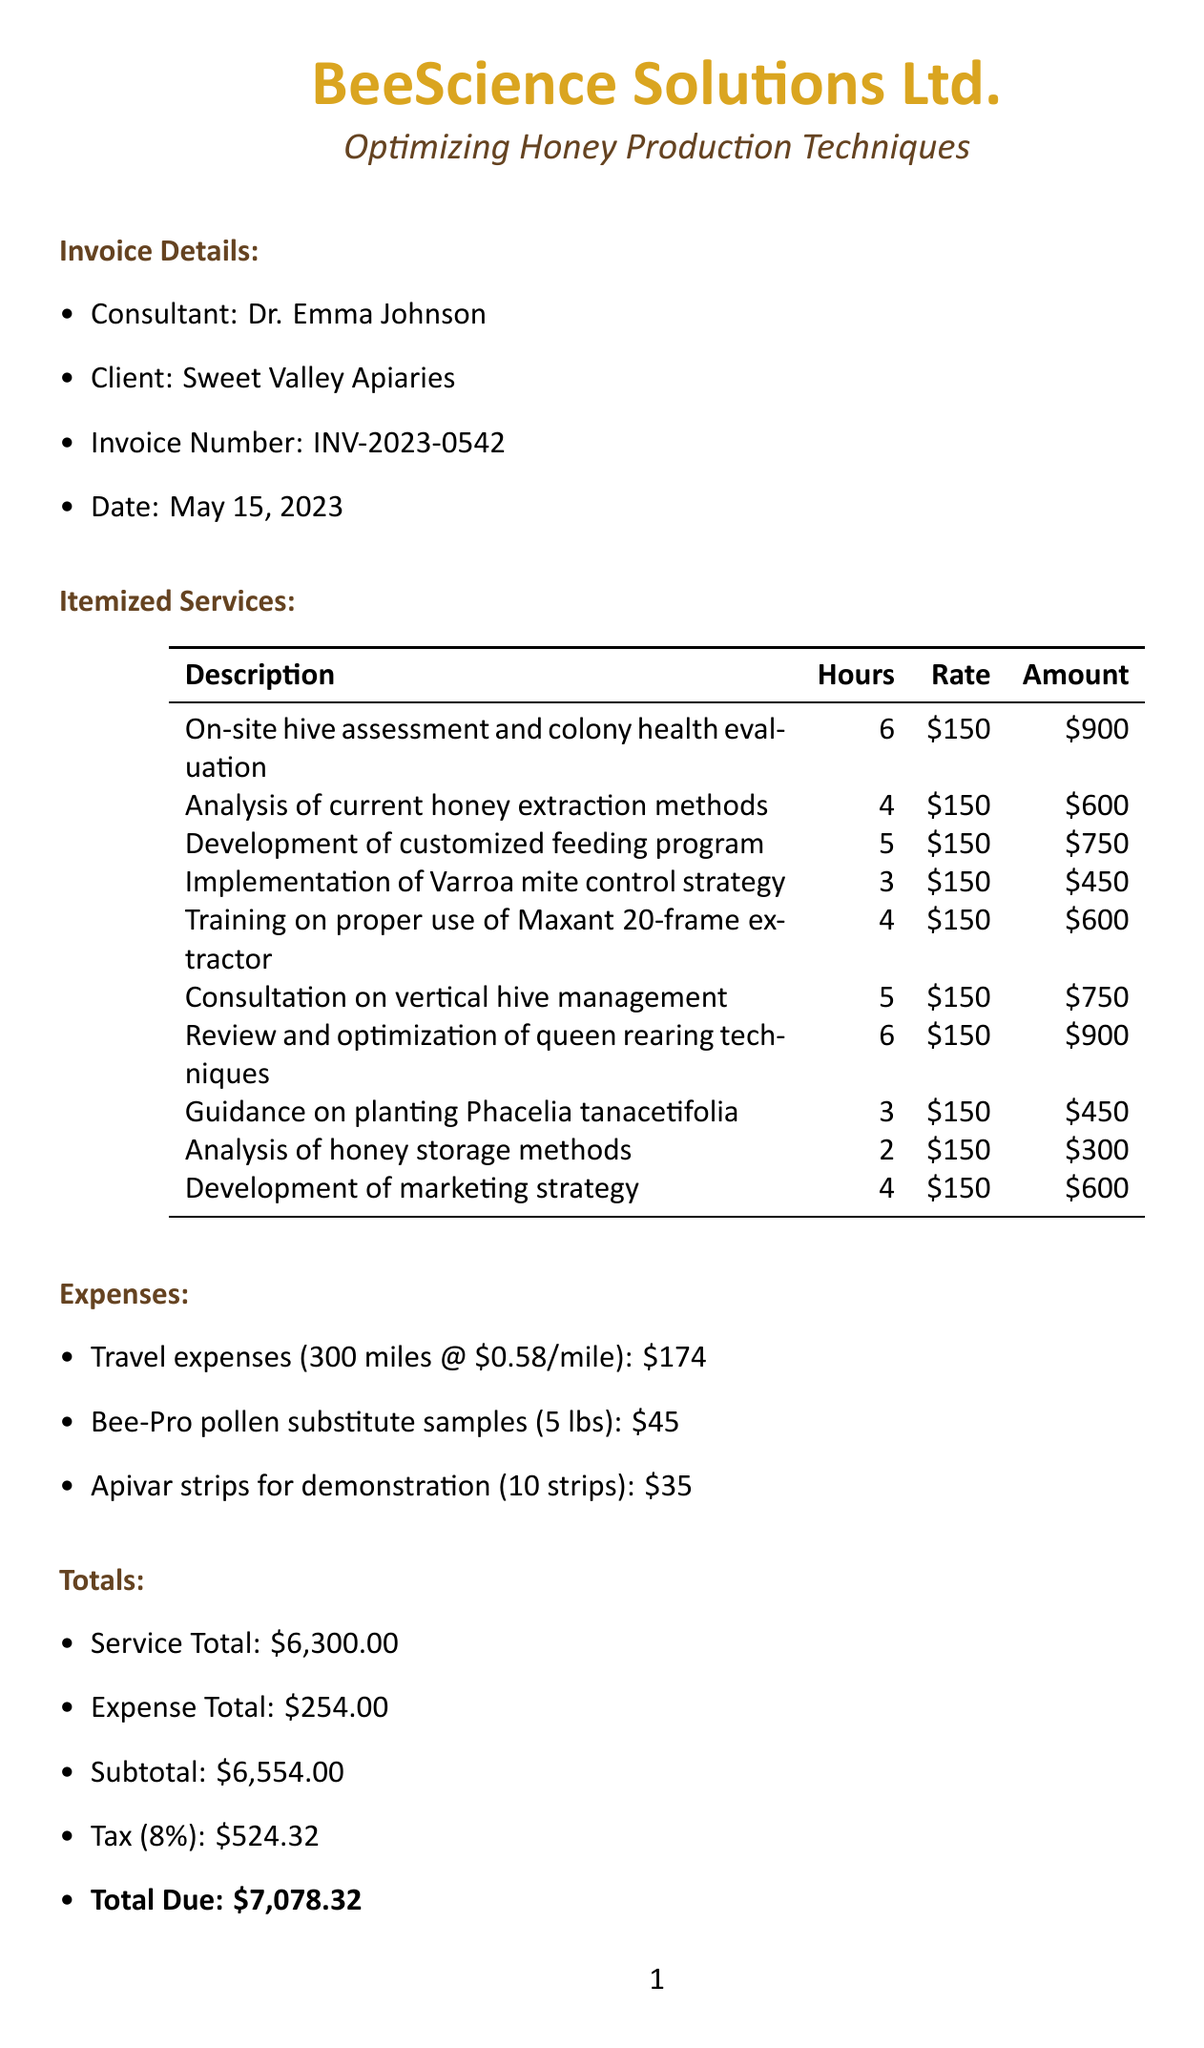what is the invoice number? The invoice number is listed in the invoice details section of the document.
Answer: INV-2023-0542 who is the consultant? The consultant's name is provided in the invoice details section.
Answer: Dr. Emma Johnson what is the date of the invoice? The date is specified in the invoice details section.
Answer: May 15, 2023 how many hours were spent on the on-site hive assessment? The hours spent on this service are indicated in the itemized services list.
Answer: 6 what is the total due amount? The total due is calculated at the end of the document, bringing together all services and expenses.
Answer: 7,078.32 how many services are listed in the itemized services section? The number of services is reflected in the enumerated list in the document.
Answer: 10 what is the expense for travel? Travel expenses are detailed in the expenses section of the document.
Answer: 174 what method of payment is accepted? The payment methods are clearly outlined at the end of the document.
Answer: Check payable to BeeScience Solutions Ltd what percentage is the tax rate applied to the subtotal? The tax rate is mentioned in the totals section of the document.
Answer: 8% what kind of program was developed involving pollen substitute? The description of the developed program is provided in the itemized services section.
Answer: Customized feeding program using Bee-Pro pollen substitute 